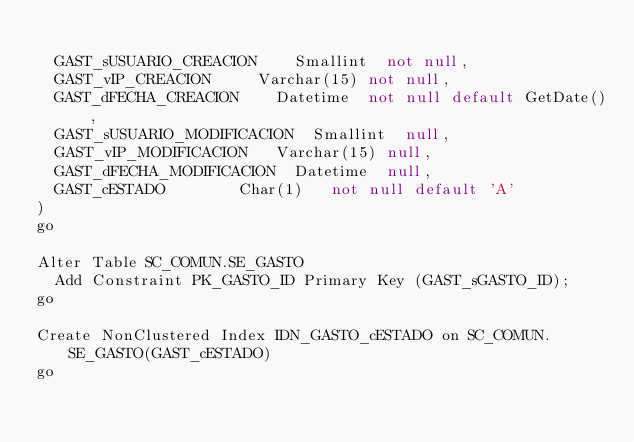<code> <loc_0><loc_0><loc_500><loc_500><_SQL_>	
	GAST_sUSUARIO_CREACION		Smallint	not null,
	GAST_vIP_CREACION			Varchar(15)	not null,
	GAST_dFECHA_CREACION		Datetime	not null default GetDate(),
	GAST_sUSUARIO_MODIFICACION	Smallint	null,
	GAST_vIP_MODIFICACION		Varchar(15)	null,
	GAST_dFECHA_MODIFICACION	Datetime	null,
	GAST_cESTADO				Char(1)		not null default 'A'
)	
go

Alter Table SC_COMUN.SE_GASTO
	Add Constraint PK_GASTO_ID Primary Key (GAST_sGASTO_ID);
go

Create NonClustered Index IDN_GASTO_cESTADO on SC_COMUN.SE_GASTO(GAST_cESTADO)
go</code> 